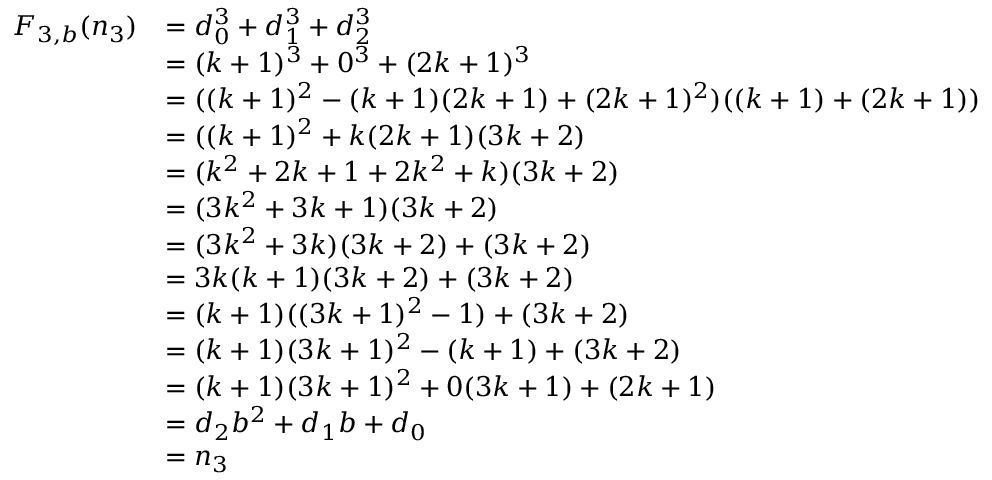<formula> <loc_0><loc_0><loc_500><loc_500>{ \begin{array} { r l } { F _ { 3 , b } ( n _ { 3 } ) } & { = d _ { 0 } ^ { 3 } + d _ { 1 } ^ { 3 } + d _ { 2 } ^ { 3 } } \\ & { = ( k + 1 ) ^ { 3 } + 0 ^ { 3 } + ( 2 k + 1 ) ^ { 3 } } \\ & { = ( ( k + 1 ) ^ { 2 } - ( k + 1 ) ( 2 k + 1 ) + ( 2 k + 1 ) ^ { 2 } ) ( ( k + 1 ) + ( 2 k + 1 ) ) } \\ & { = ( ( k + 1 ) ^ { 2 } + k ( 2 k + 1 ) ( 3 k + 2 ) } \\ & { = ( k ^ { 2 } + 2 k + 1 + 2 k ^ { 2 } + k ) ( 3 k + 2 ) } \\ & { = ( 3 k ^ { 2 } + 3 k + 1 ) ( 3 k + 2 ) } \\ & { = ( 3 k ^ { 2 } + 3 k ) ( 3 k + 2 ) + ( 3 k + 2 ) } \\ & { = 3 k ( k + 1 ) ( 3 k + 2 ) + ( 3 k + 2 ) } \\ & { = ( k + 1 ) ( ( 3 k + 1 ) ^ { 2 } - 1 ) + ( 3 k + 2 ) } \\ & { = ( k + 1 ) ( 3 k + 1 ) ^ { 2 } - ( k + 1 ) + ( 3 k + 2 ) } \\ & { = ( k + 1 ) ( 3 k + 1 ) ^ { 2 } + 0 ( 3 k + 1 ) + ( 2 k + 1 ) } \\ & { = d _ { 2 } b ^ { 2 } + d _ { 1 } b + d _ { 0 } } \\ & { = n _ { 3 } } \end{array} }</formula> 